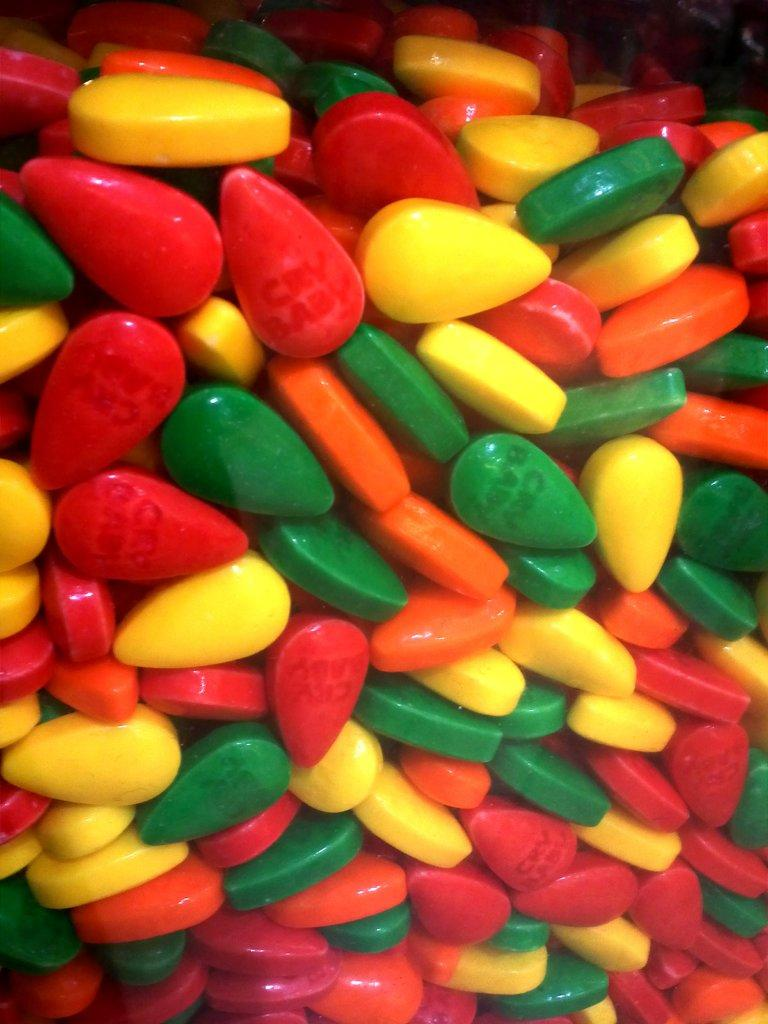What type of candy is present in the image? There are chocolate gems in the image. Can you describe the appearance of the chocolate gems? The chocolate gems are small, round, and appear to be coated in a colorful candy shell. How might someone consume the chocolate gems in the image? Someone might consume the chocolate gems by picking them up with their fingers or using a utensil to scoop them up. What type of request is the governor making in the image? There is no governor or request present in the image; it only features chocolate gems. 